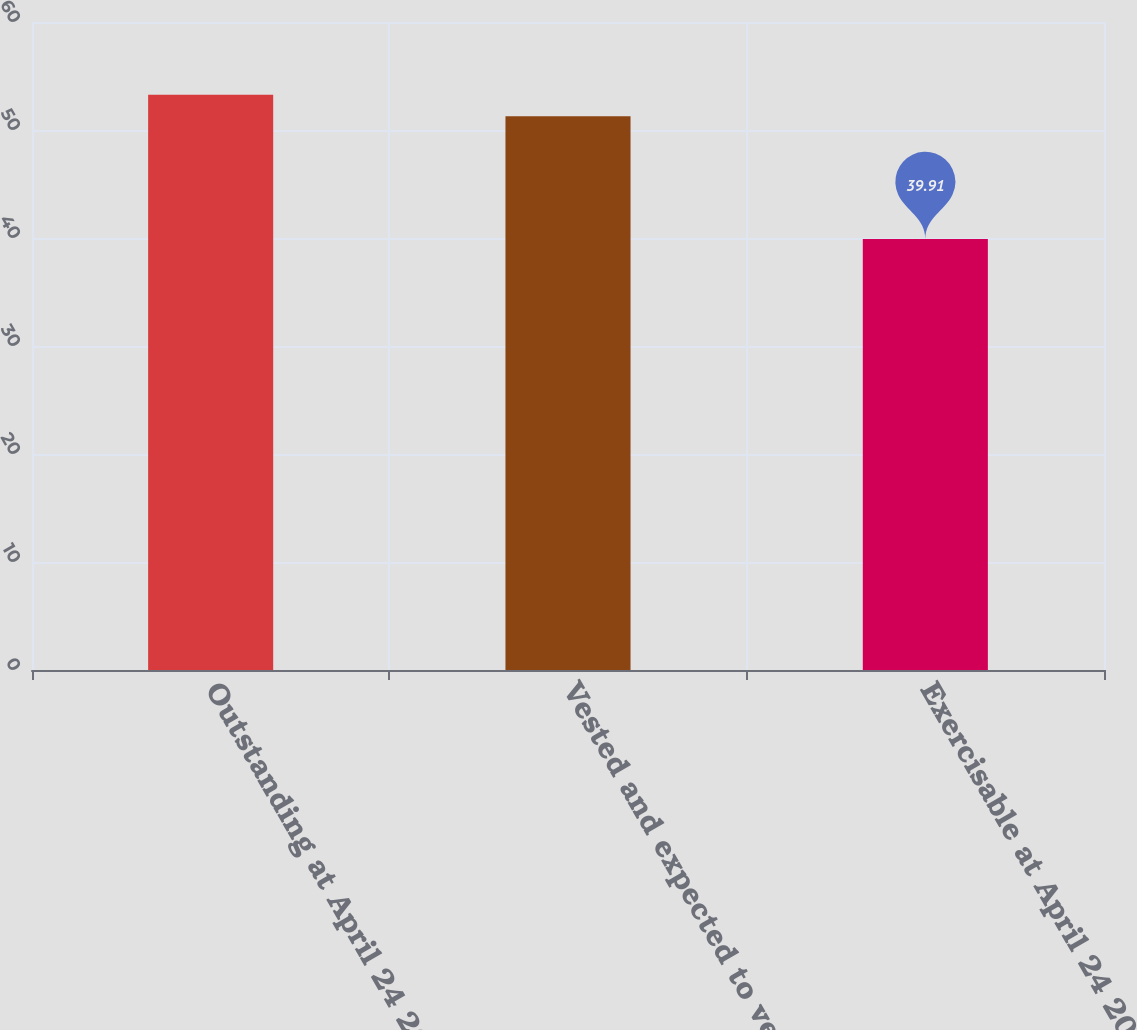Convert chart. <chart><loc_0><loc_0><loc_500><loc_500><bar_chart><fcel>Outstanding at April 24 2015<fcel>Vested and expected to vest at<fcel>Exercisable at April 24 2015<nl><fcel>53.27<fcel>51.27<fcel>39.91<nl></chart> 